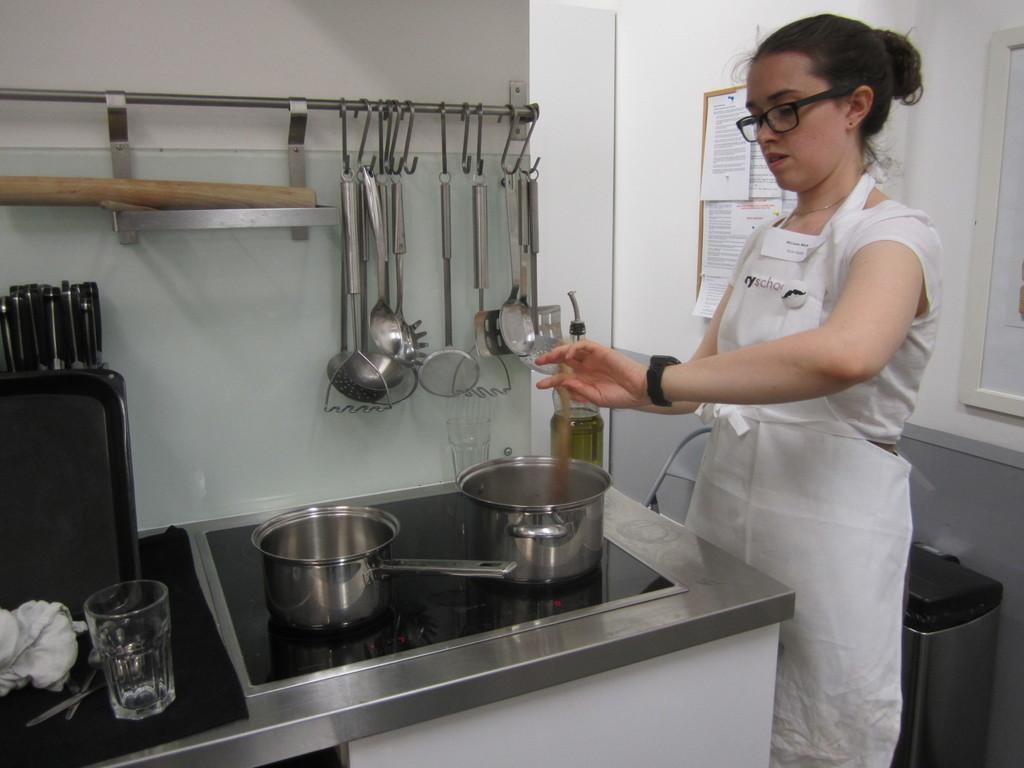In one or two sentences, can you explain what this image depicts? In this image there is a cabinet having vessels, glass, pans, bottle and few objects are on it. Right side there is a woman wearing an apron. She is standing. Behind her there is an object on the floor. There is a chair kept near the wall which is having a board attached to it. On the board few posters are pinned to it. Few kitchen tools are hanging from the metal rod. 